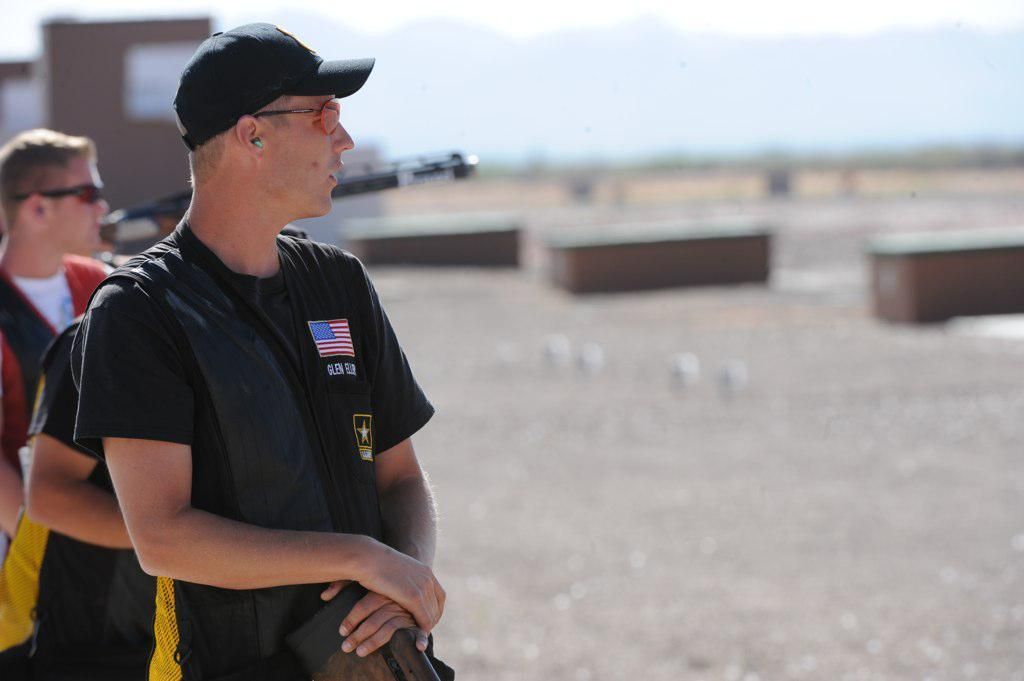What can be seen on the left side of the image? There are persons standing on the left side of the image. What structure is located in the center of the image? There is a house in the center of the image. How would you describe the background of the image? The background of the image is blurry. What type of heart-shaped object can be seen in the image? There is no heart-shaped object present in the image. What story is being told by the persons standing on the left side of the image? The image does not provide any information about a story being told by the persons; it only shows them standing on the left side. 